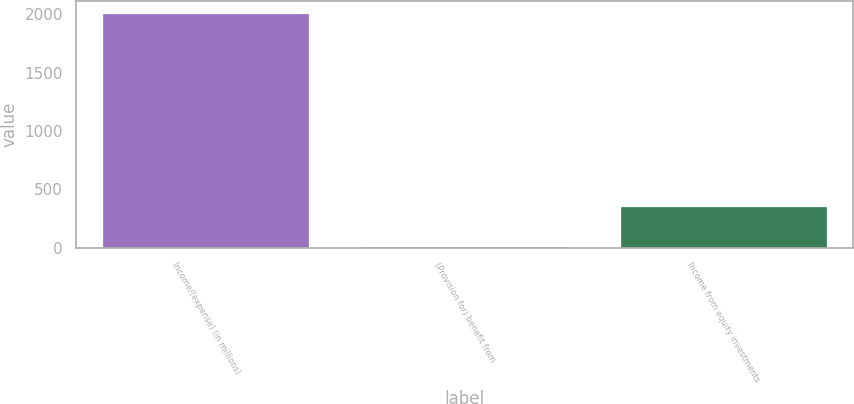Convert chart to OTSL. <chart><loc_0><loc_0><loc_500><loc_500><bar_chart><fcel>Income/(expense) (in millions)<fcel>(Provision for) benefit from<fcel>Income from equity investments<nl><fcel>2017<fcel>17<fcel>357<nl></chart> 